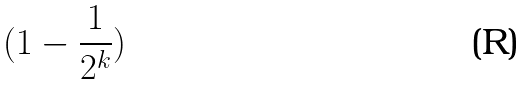Convert formula to latex. <formula><loc_0><loc_0><loc_500><loc_500>( 1 - \frac { 1 } { 2 ^ { k } } )</formula> 